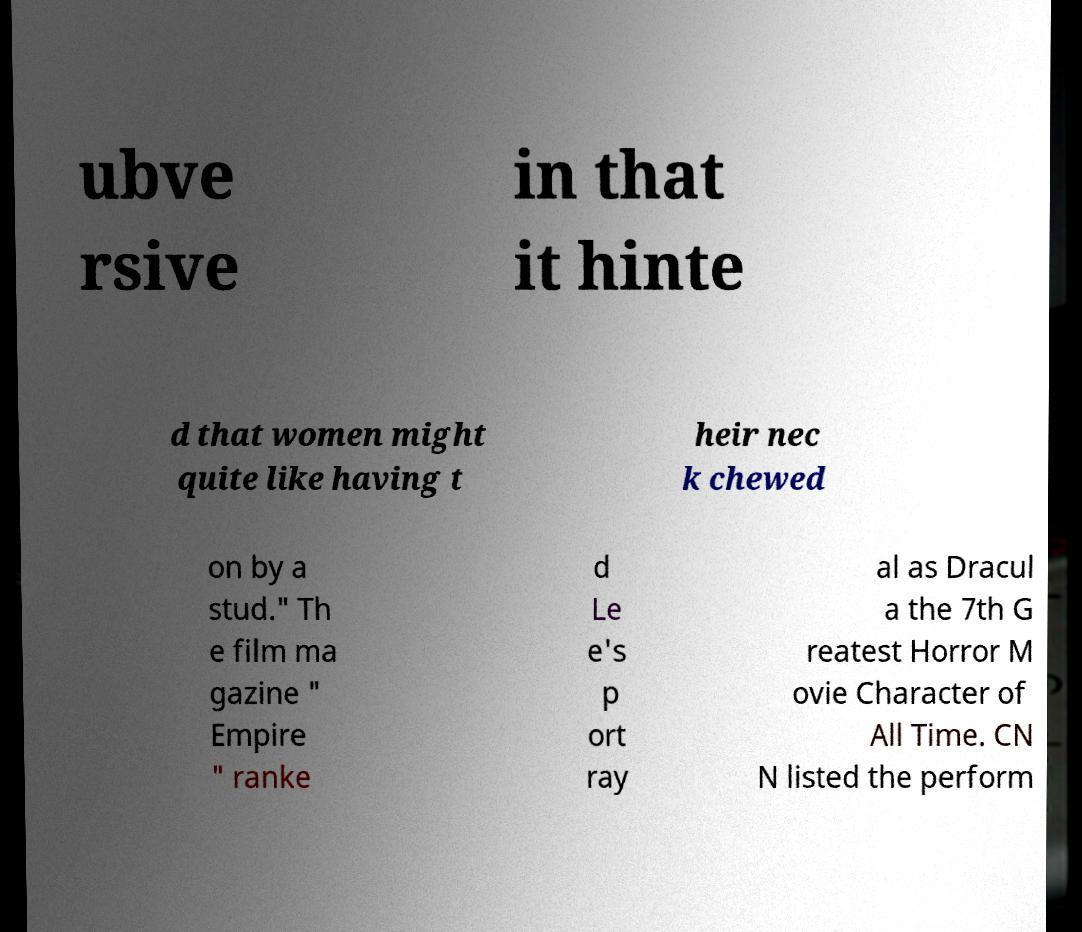Please identify and transcribe the text found in this image. ubve rsive in that it hinte d that women might quite like having t heir nec k chewed on by a stud." Th e film ma gazine " Empire " ranke d Le e's p ort ray al as Dracul a the 7th G reatest Horror M ovie Character of All Time. CN N listed the perform 